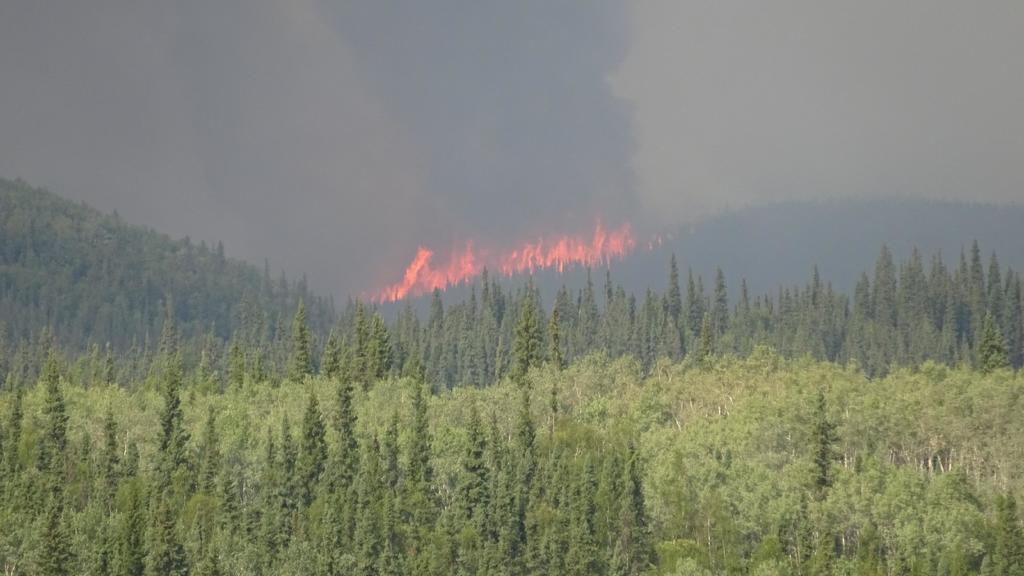Can you describe this image briefly? Front we can see trees. Background there is a smoke, fire and sky. 